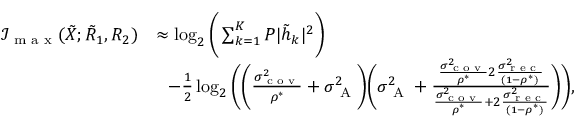Convert formula to latex. <formula><loc_0><loc_0><loc_500><loc_500>\begin{array} { r l } { \mathcal { I } _ { \max } ( { { { \tilde { X } } } } ; { { { \tilde { R } } } _ { 1 } } , { { R } _ { 2 } } ) } & { \approx \log _ { 2 } \left ( \sum _ { k = 1 } ^ { K } P | \tilde { h } _ { k } | ^ { 2 } \right ) } \\ & { \, - \frac { 1 } { 2 } \log _ { 2 } \left ( \left ( { { \frac { \sigma _ { c o v } ^ { 2 } } { \rho ^ { * } } } } + \sigma _ { A } ^ { 2 } \right ) \left ( { \sigma _ { A } ^ { 2 } } + \frac { { { \frac { \sigma _ { c o v } ^ { 2 } } { \rho ^ { * } } } } 2 \frac { \sigma _ { r e c } ^ { 2 } } { ( 1 - \rho ^ { * } ) } } { { { \frac { \sigma _ { c o v } ^ { 2 } } { \rho ^ { * } } } } + 2 \frac { \sigma _ { r e c } ^ { 2 } } { ( 1 - \rho ^ { * } ) } } \right ) \right ) , } \end{array}</formula> 